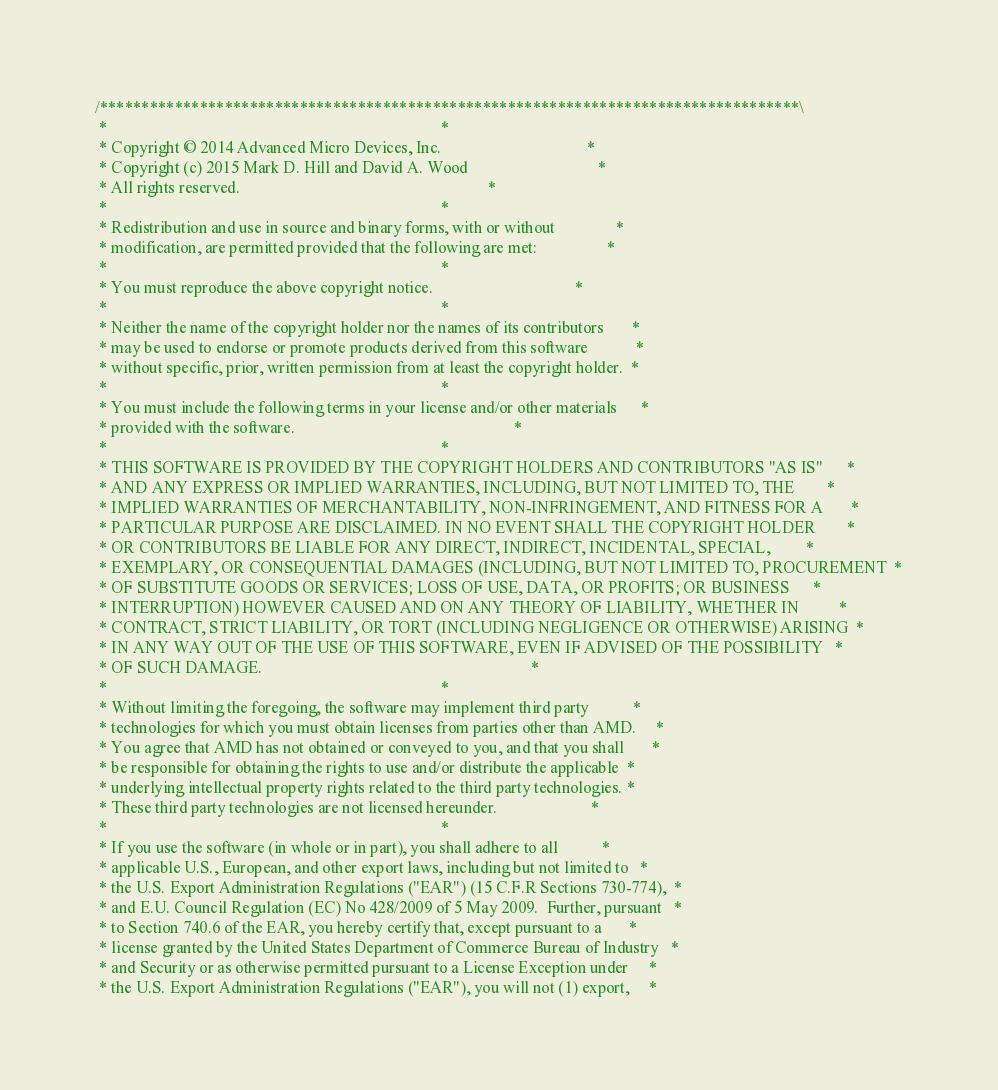Convert code to text. <code><loc_0><loc_0><loc_500><loc_500><_Cuda_>/************************************************************************************\
 *                                                                                  *
 * Copyright © 2014 Advanced Micro Devices, Inc.                                    *
 * Copyright (c) 2015 Mark D. Hill and David A. Wood                                *
 * All rights reserved.                                                             *
 *                                                                                  *
 * Redistribution and use in source and binary forms, with or without               *
 * modification, are permitted provided that the following are met:                 *
 *                                                                                  *
 * You must reproduce the above copyright notice.                                   *
 *                                                                                  *
 * Neither the name of the copyright holder nor the names of its contributors       *
 * may be used to endorse or promote products derived from this software            *
 * without specific, prior, written permission from at least the copyright holder.  *
 *                                                                                  *
 * You must include the following terms in your license and/or other materials      *
 * provided with the software.                                                      *
 *                                                                                  *
 * THIS SOFTWARE IS PROVIDED BY THE COPYRIGHT HOLDERS AND CONTRIBUTORS "AS IS"      *
 * AND ANY EXPRESS OR IMPLIED WARRANTIES, INCLUDING, BUT NOT LIMITED TO, THE        *
 * IMPLIED WARRANTIES OF MERCHANTABILITY, NON-INFRINGEMENT, AND FITNESS FOR A       *
 * PARTICULAR PURPOSE ARE DISCLAIMED. IN NO EVENT SHALL THE COPYRIGHT HOLDER        *
 * OR CONTRIBUTORS BE LIABLE FOR ANY DIRECT, INDIRECT, INCIDENTAL, SPECIAL,         *
 * EXEMPLARY, OR CONSEQUENTIAL DAMAGES (INCLUDING, BUT NOT LIMITED TO, PROCUREMENT  *
 * OF SUBSTITUTE GOODS OR SERVICES; LOSS OF USE, DATA, OR PROFITS; OR BUSINESS      *
 * INTERRUPTION) HOWEVER CAUSED AND ON ANY THEORY OF LIABILITY, WHETHER IN          *
 * CONTRACT, STRICT LIABILITY, OR TORT (INCLUDING NEGLIGENCE OR OTHERWISE) ARISING  *
 * IN ANY WAY OUT OF THE USE OF THIS SOFTWARE, EVEN IF ADVISED OF THE POSSIBILITY   *
 * OF SUCH DAMAGE.                                                                  *
 *                                                                                  *
 * Without limiting the foregoing, the software may implement third party           *
 * technologies for which you must obtain licenses from parties other than AMD.     *
 * You agree that AMD has not obtained or conveyed to you, and that you shall       *
 * be responsible for obtaining the rights to use and/or distribute the applicable  *
 * underlying intellectual property rights related to the third party technologies. *
 * These third party technologies are not licensed hereunder.                       *
 *                                                                                  *
 * If you use the software (in whole or in part), you shall adhere to all           *
 * applicable U.S., European, and other export laws, including but not limited to   *
 * the U.S. Export Administration Regulations ("EAR") (15 C.F.R Sections 730-774),  *
 * and E.U. Council Regulation (EC) No 428/2009 of 5 May 2009.  Further, pursuant   *
 * to Section 740.6 of the EAR, you hereby certify that, except pursuant to a       *
 * license granted by the United States Department of Commerce Bureau of Industry   *
 * and Security or as otherwise permitted pursuant to a License Exception under     *
 * the U.S. Export Administration Regulations ("EAR"), you will not (1) export,     *</code> 